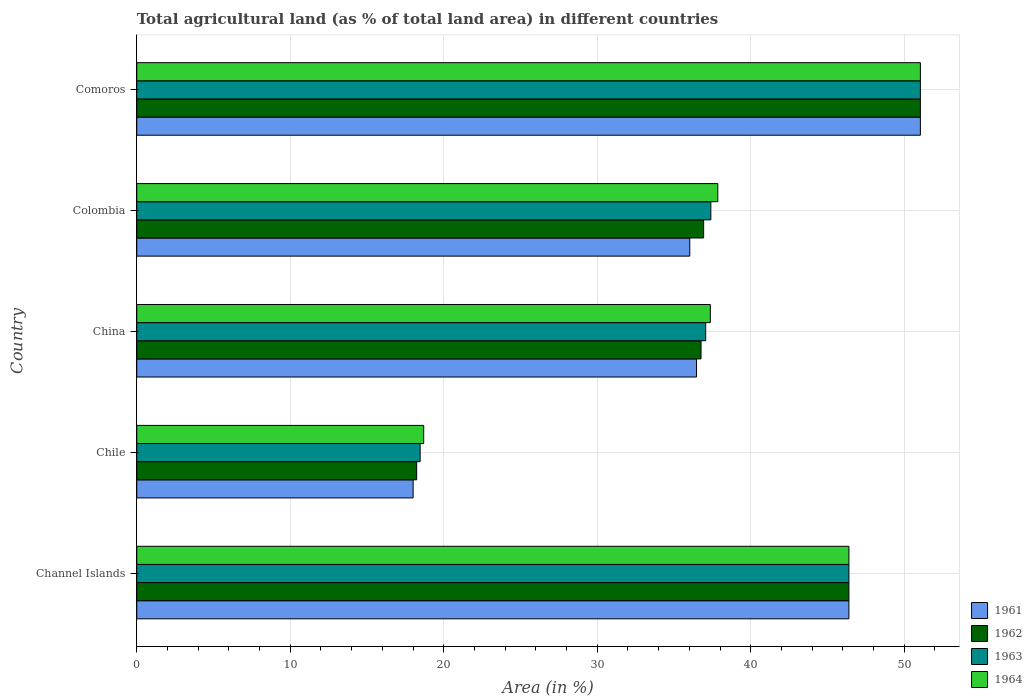In how many cases, is the number of bars for a given country not equal to the number of legend labels?
Your answer should be very brief. 0. What is the percentage of agricultural land in 1962 in Channel Islands?
Ensure brevity in your answer.  46.39. Across all countries, what is the maximum percentage of agricultural land in 1963?
Keep it short and to the point. 51.05. Across all countries, what is the minimum percentage of agricultural land in 1963?
Provide a short and direct response. 18.46. In which country was the percentage of agricultural land in 1963 maximum?
Offer a terse response. Comoros. What is the total percentage of agricultural land in 1962 in the graph?
Offer a terse response. 189.36. What is the difference between the percentage of agricultural land in 1962 in China and that in Comoros?
Your answer should be very brief. -14.29. What is the difference between the percentage of agricultural land in 1962 in Colombia and the percentage of agricultural land in 1963 in Chile?
Your answer should be very brief. 18.47. What is the average percentage of agricultural land in 1963 per country?
Your answer should be very brief. 38.07. In how many countries, is the percentage of agricultural land in 1962 greater than 22 %?
Offer a very short reply. 4. What is the ratio of the percentage of agricultural land in 1961 in Channel Islands to that in Colombia?
Your answer should be compact. 1.29. Is the percentage of agricultural land in 1964 in Colombia less than that in Comoros?
Offer a very short reply. Yes. Is the difference between the percentage of agricultural land in 1962 in Channel Islands and Chile greater than the difference between the percentage of agricultural land in 1963 in Channel Islands and Chile?
Your answer should be compact. Yes. What is the difference between the highest and the second highest percentage of agricultural land in 1963?
Your answer should be very brief. 4.66. What is the difference between the highest and the lowest percentage of agricultural land in 1962?
Provide a succinct answer. 32.82. In how many countries, is the percentage of agricultural land in 1961 greater than the average percentage of agricultural land in 1961 taken over all countries?
Ensure brevity in your answer.  2. What does the 1st bar from the top in Colombia represents?
Your answer should be very brief. 1964. How many bars are there?
Offer a very short reply. 20. How many countries are there in the graph?
Make the answer very short. 5. Are the values on the major ticks of X-axis written in scientific E-notation?
Your response must be concise. No. Where does the legend appear in the graph?
Provide a succinct answer. Bottom right. How many legend labels are there?
Provide a short and direct response. 4. What is the title of the graph?
Offer a terse response. Total agricultural land (as % of total land area) in different countries. Does "1964" appear as one of the legend labels in the graph?
Provide a succinct answer. Yes. What is the label or title of the X-axis?
Your answer should be very brief. Area (in %). What is the label or title of the Y-axis?
Make the answer very short. Country. What is the Area (in %) of 1961 in Channel Islands?
Your response must be concise. 46.39. What is the Area (in %) in 1962 in Channel Islands?
Provide a succinct answer. 46.39. What is the Area (in %) in 1963 in Channel Islands?
Provide a succinct answer. 46.39. What is the Area (in %) of 1964 in Channel Islands?
Provide a short and direct response. 46.39. What is the Area (in %) of 1961 in Chile?
Offer a terse response. 18. What is the Area (in %) in 1962 in Chile?
Your answer should be compact. 18.23. What is the Area (in %) of 1963 in Chile?
Keep it short and to the point. 18.46. What is the Area (in %) of 1964 in Chile?
Your response must be concise. 18.69. What is the Area (in %) in 1961 in China?
Make the answer very short. 36.47. What is the Area (in %) in 1962 in China?
Offer a very short reply. 36.76. What is the Area (in %) of 1963 in China?
Your answer should be very brief. 37.06. What is the Area (in %) of 1964 in China?
Provide a succinct answer. 37.37. What is the Area (in %) in 1961 in Colombia?
Your response must be concise. 36.03. What is the Area (in %) in 1962 in Colombia?
Give a very brief answer. 36.93. What is the Area (in %) of 1963 in Colombia?
Your response must be concise. 37.4. What is the Area (in %) in 1964 in Colombia?
Your answer should be compact. 37.85. What is the Area (in %) of 1961 in Comoros?
Your answer should be very brief. 51.05. What is the Area (in %) of 1962 in Comoros?
Offer a very short reply. 51.05. What is the Area (in %) in 1963 in Comoros?
Offer a terse response. 51.05. What is the Area (in %) of 1964 in Comoros?
Ensure brevity in your answer.  51.05. Across all countries, what is the maximum Area (in %) of 1961?
Give a very brief answer. 51.05. Across all countries, what is the maximum Area (in %) in 1962?
Provide a short and direct response. 51.05. Across all countries, what is the maximum Area (in %) of 1963?
Keep it short and to the point. 51.05. Across all countries, what is the maximum Area (in %) in 1964?
Provide a short and direct response. 51.05. Across all countries, what is the minimum Area (in %) in 1961?
Your answer should be compact. 18. Across all countries, what is the minimum Area (in %) of 1962?
Your response must be concise. 18.23. Across all countries, what is the minimum Area (in %) of 1963?
Offer a terse response. 18.46. Across all countries, what is the minimum Area (in %) in 1964?
Your response must be concise. 18.69. What is the total Area (in %) of 1961 in the graph?
Offer a very short reply. 187.93. What is the total Area (in %) of 1962 in the graph?
Give a very brief answer. 189.36. What is the total Area (in %) in 1963 in the graph?
Your answer should be compact. 190.36. What is the total Area (in %) of 1964 in the graph?
Offer a terse response. 191.35. What is the difference between the Area (in %) of 1961 in Channel Islands and that in Chile?
Keep it short and to the point. 28.39. What is the difference between the Area (in %) in 1962 in Channel Islands and that in Chile?
Your answer should be very brief. 28.16. What is the difference between the Area (in %) in 1963 in Channel Islands and that in Chile?
Keep it short and to the point. 27.93. What is the difference between the Area (in %) in 1964 in Channel Islands and that in Chile?
Ensure brevity in your answer.  27.7. What is the difference between the Area (in %) in 1961 in Channel Islands and that in China?
Your answer should be compact. 9.93. What is the difference between the Area (in %) in 1962 in Channel Islands and that in China?
Your answer should be very brief. 9.63. What is the difference between the Area (in %) in 1963 in Channel Islands and that in China?
Provide a succinct answer. 9.33. What is the difference between the Area (in %) in 1964 in Channel Islands and that in China?
Provide a succinct answer. 9.03. What is the difference between the Area (in %) of 1961 in Channel Islands and that in Colombia?
Your response must be concise. 10.37. What is the difference between the Area (in %) of 1962 in Channel Islands and that in Colombia?
Your answer should be very brief. 9.46. What is the difference between the Area (in %) in 1963 in Channel Islands and that in Colombia?
Give a very brief answer. 8.99. What is the difference between the Area (in %) of 1964 in Channel Islands and that in Colombia?
Give a very brief answer. 8.54. What is the difference between the Area (in %) of 1961 in Channel Islands and that in Comoros?
Your answer should be compact. -4.66. What is the difference between the Area (in %) of 1962 in Channel Islands and that in Comoros?
Provide a short and direct response. -4.66. What is the difference between the Area (in %) of 1963 in Channel Islands and that in Comoros?
Make the answer very short. -4.66. What is the difference between the Area (in %) in 1964 in Channel Islands and that in Comoros?
Make the answer very short. -4.66. What is the difference between the Area (in %) of 1961 in Chile and that in China?
Your response must be concise. -18.46. What is the difference between the Area (in %) in 1962 in Chile and that in China?
Your response must be concise. -18.53. What is the difference between the Area (in %) of 1963 in Chile and that in China?
Your answer should be compact. -18.6. What is the difference between the Area (in %) in 1964 in Chile and that in China?
Your answer should be compact. -18.67. What is the difference between the Area (in %) of 1961 in Chile and that in Colombia?
Your response must be concise. -18.02. What is the difference between the Area (in %) of 1962 in Chile and that in Colombia?
Your answer should be very brief. -18.7. What is the difference between the Area (in %) in 1963 in Chile and that in Colombia?
Your answer should be compact. -18.94. What is the difference between the Area (in %) of 1964 in Chile and that in Colombia?
Make the answer very short. -19.16. What is the difference between the Area (in %) of 1961 in Chile and that in Comoros?
Offer a very short reply. -33.04. What is the difference between the Area (in %) of 1962 in Chile and that in Comoros?
Keep it short and to the point. -32.82. What is the difference between the Area (in %) in 1963 in Chile and that in Comoros?
Your answer should be compact. -32.59. What is the difference between the Area (in %) of 1964 in Chile and that in Comoros?
Your answer should be compact. -32.36. What is the difference between the Area (in %) of 1961 in China and that in Colombia?
Your answer should be very brief. 0.44. What is the difference between the Area (in %) of 1962 in China and that in Colombia?
Your answer should be very brief. -0.17. What is the difference between the Area (in %) in 1963 in China and that in Colombia?
Offer a terse response. -0.34. What is the difference between the Area (in %) of 1964 in China and that in Colombia?
Your answer should be very brief. -0.48. What is the difference between the Area (in %) of 1961 in China and that in Comoros?
Keep it short and to the point. -14.58. What is the difference between the Area (in %) in 1962 in China and that in Comoros?
Your response must be concise. -14.29. What is the difference between the Area (in %) of 1963 in China and that in Comoros?
Provide a short and direct response. -13.99. What is the difference between the Area (in %) of 1964 in China and that in Comoros?
Provide a succinct answer. -13.68. What is the difference between the Area (in %) in 1961 in Colombia and that in Comoros?
Offer a very short reply. -15.02. What is the difference between the Area (in %) of 1962 in Colombia and that in Comoros?
Your response must be concise. -14.12. What is the difference between the Area (in %) in 1963 in Colombia and that in Comoros?
Your answer should be compact. -13.65. What is the difference between the Area (in %) in 1964 in Colombia and that in Comoros?
Keep it short and to the point. -13.2. What is the difference between the Area (in %) in 1961 in Channel Islands and the Area (in %) in 1962 in Chile?
Offer a very short reply. 28.16. What is the difference between the Area (in %) in 1961 in Channel Islands and the Area (in %) in 1963 in Chile?
Give a very brief answer. 27.93. What is the difference between the Area (in %) of 1961 in Channel Islands and the Area (in %) of 1964 in Chile?
Keep it short and to the point. 27.7. What is the difference between the Area (in %) in 1962 in Channel Islands and the Area (in %) in 1963 in Chile?
Offer a very short reply. 27.93. What is the difference between the Area (in %) in 1962 in Channel Islands and the Area (in %) in 1964 in Chile?
Provide a succinct answer. 27.7. What is the difference between the Area (in %) in 1963 in Channel Islands and the Area (in %) in 1964 in Chile?
Make the answer very short. 27.7. What is the difference between the Area (in %) in 1961 in Channel Islands and the Area (in %) in 1962 in China?
Keep it short and to the point. 9.63. What is the difference between the Area (in %) of 1961 in Channel Islands and the Area (in %) of 1963 in China?
Keep it short and to the point. 9.33. What is the difference between the Area (in %) in 1961 in Channel Islands and the Area (in %) in 1964 in China?
Offer a terse response. 9.03. What is the difference between the Area (in %) of 1962 in Channel Islands and the Area (in %) of 1963 in China?
Give a very brief answer. 9.33. What is the difference between the Area (in %) in 1962 in Channel Islands and the Area (in %) in 1964 in China?
Offer a very short reply. 9.03. What is the difference between the Area (in %) in 1963 in Channel Islands and the Area (in %) in 1964 in China?
Ensure brevity in your answer.  9.03. What is the difference between the Area (in %) of 1961 in Channel Islands and the Area (in %) of 1962 in Colombia?
Keep it short and to the point. 9.46. What is the difference between the Area (in %) in 1961 in Channel Islands and the Area (in %) in 1963 in Colombia?
Your answer should be very brief. 8.99. What is the difference between the Area (in %) of 1961 in Channel Islands and the Area (in %) of 1964 in Colombia?
Your answer should be very brief. 8.54. What is the difference between the Area (in %) in 1962 in Channel Islands and the Area (in %) in 1963 in Colombia?
Keep it short and to the point. 8.99. What is the difference between the Area (in %) in 1962 in Channel Islands and the Area (in %) in 1964 in Colombia?
Make the answer very short. 8.54. What is the difference between the Area (in %) of 1963 in Channel Islands and the Area (in %) of 1964 in Colombia?
Your response must be concise. 8.54. What is the difference between the Area (in %) in 1961 in Channel Islands and the Area (in %) in 1962 in Comoros?
Your answer should be very brief. -4.66. What is the difference between the Area (in %) in 1961 in Channel Islands and the Area (in %) in 1963 in Comoros?
Your response must be concise. -4.66. What is the difference between the Area (in %) in 1961 in Channel Islands and the Area (in %) in 1964 in Comoros?
Offer a very short reply. -4.66. What is the difference between the Area (in %) of 1962 in Channel Islands and the Area (in %) of 1963 in Comoros?
Make the answer very short. -4.66. What is the difference between the Area (in %) in 1962 in Channel Islands and the Area (in %) in 1964 in Comoros?
Keep it short and to the point. -4.66. What is the difference between the Area (in %) of 1963 in Channel Islands and the Area (in %) of 1964 in Comoros?
Provide a succinct answer. -4.66. What is the difference between the Area (in %) in 1961 in Chile and the Area (in %) in 1962 in China?
Keep it short and to the point. -18.76. What is the difference between the Area (in %) in 1961 in Chile and the Area (in %) in 1963 in China?
Give a very brief answer. -19.06. What is the difference between the Area (in %) in 1961 in Chile and the Area (in %) in 1964 in China?
Offer a very short reply. -19.36. What is the difference between the Area (in %) of 1962 in Chile and the Area (in %) of 1963 in China?
Offer a very short reply. -18.83. What is the difference between the Area (in %) in 1962 in Chile and the Area (in %) in 1964 in China?
Provide a succinct answer. -19.13. What is the difference between the Area (in %) in 1963 in Chile and the Area (in %) in 1964 in China?
Ensure brevity in your answer.  -18.91. What is the difference between the Area (in %) of 1961 in Chile and the Area (in %) of 1962 in Colombia?
Offer a very short reply. -18.93. What is the difference between the Area (in %) of 1961 in Chile and the Area (in %) of 1963 in Colombia?
Offer a terse response. -19.39. What is the difference between the Area (in %) in 1961 in Chile and the Area (in %) in 1964 in Colombia?
Provide a succinct answer. -19.85. What is the difference between the Area (in %) of 1962 in Chile and the Area (in %) of 1963 in Colombia?
Provide a short and direct response. -19.17. What is the difference between the Area (in %) of 1962 in Chile and the Area (in %) of 1964 in Colombia?
Make the answer very short. -19.62. What is the difference between the Area (in %) of 1963 in Chile and the Area (in %) of 1964 in Colombia?
Give a very brief answer. -19.39. What is the difference between the Area (in %) in 1961 in Chile and the Area (in %) in 1962 in Comoros?
Ensure brevity in your answer.  -33.04. What is the difference between the Area (in %) in 1961 in Chile and the Area (in %) in 1963 in Comoros?
Make the answer very short. -33.04. What is the difference between the Area (in %) of 1961 in Chile and the Area (in %) of 1964 in Comoros?
Make the answer very short. -33.04. What is the difference between the Area (in %) of 1962 in Chile and the Area (in %) of 1963 in Comoros?
Keep it short and to the point. -32.82. What is the difference between the Area (in %) in 1962 in Chile and the Area (in %) in 1964 in Comoros?
Your answer should be very brief. -32.82. What is the difference between the Area (in %) in 1963 in Chile and the Area (in %) in 1964 in Comoros?
Keep it short and to the point. -32.59. What is the difference between the Area (in %) of 1961 in China and the Area (in %) of 1962 in Colombia?
Keep it short and to the point. -0.46. What is the difference between the Area (in %) in 1961 in China and the Area (in %) in 1963 in Colombia?
Offer a very short reply. -0.93. What is the difference between the Area (in %) of 1961 in China and the Area (in %) of 1964 in Colombia?
Keep it short and to the point. -1.38. What is the difference between the Area (in %) in 1962 in China and the Area (in %) in 1963 in Colombia?
Keep it short and to the point. -0.64. What is the difference between the Area (in %) of 1962 in China and the Area (in %) of 1964 in Colombia?
Make the answer very short. -1.09. What is the difference between the Area (in %) of 1963 in China and the Area (in %) of 1964 in Colombia?
Your answer should be compact. -0.79. What is the difference between the Area (in %) in 1961 in China and the Area (in %) in 1962 in Comoros?
Ensure brevity in your answer.  -14.58. What is the difference between the Area (in %) of 1961 in China and the Area (in %) of 1963 in Comoros?
Make the answer very short. -14.58. What is the difference between the Area (in %) of 1961 in China and the Area (in %) of 1964 in Comoros?
Offer a terse response. -14.58. What is the difference between the Area (in %) of 1962 in China and the Area (in %) of 1963 in Comoros?
Give a very brief answer. -14.29. What is the difference between the Area (in %) of 1962 in China and the Area (in %) of 1964 in Comoros?
Keep it short and to the point. -14.29. What is the difference between the Area (in %) in 1963 in China and the Area (in %) in 1964 in Comoros?
Keep it short and to the point. -13.99. What is the difference between the Area (in %) of 1961 in Colombia and the Area (in %) of 1962 in Comoros?
Your answer should be very brief. -15.02. What is the difference between the Area (in %) in 1961 in Colombia and the Area (in %) in 1963 in Comoros?
Offer a very short reply. -15.02. What is the difference between the Area (in %) in 1961 in Colombia and the Area (in %) in 1964 in Comoros?
Offer a terse response. -15.02. What is the difference between the Area (in %) in 1962 in Colombia and the Area (in %) in 1963 in Comoros?
Your response must be concise. -14.12. What is the difference between the Area (in %) of 1962 in Colombia and the Area (in %) of 1964 in Comoros?
Offer a very short reply. -14.12. What is the difference between the Area (in %) of 1963 in Colombia and the Area (in %) of 1964 in Comoros?
Provide a short and direct response. -13.65. What is the average Area (in %) in 1961 per country?
Give a very brief answer. 37.59. What is the average Area (in %) of 1962 per country?
Your answer should be compact. 37.87. What is the average Area (in %) of 1963 per country?
Your response must be concise. 38.07. What is the average Area (in %) in 1964 per country?
Your response must be concise. 38.27. What is the difference between the Area (in %) in 1961 and Area (in %) in 1962 in Channel Islands?
Offer a very short reply. 0. What is the difference between the Area (in %) in 1962 and Area (in %) in 1964 in Channel Islands?
Give a very brief answer. 0. What is the difference between the Area (in %) in 1961 and Area (in %) in 1962 in Chile?
Offer a very short reply. -0.23. What is the difference between the Area (in %) in 1961 and Area (in %) in 1963 in Chile?
Your answer should be very brief. -0.46. What is the difference between the Area (in %) of 1961 and Area (in %) of 1964 in Chile?
Make the answer very short. -0.69. What is the difference between the Area (in %) of 1962 and Area (in %) of 1963 in Chile?
Make the answer very short. -0.23. What is the difference between the Area (in %) in 1962 and Area (in %) in 1964 in Chile?
Ensure brevity in your answer.  -0.46. What is the difference between the Area (in %) in 1963 and Area (in %) in 1964 in Chile?
Keep it short and to the point. -0.23. What is the difference between the Area (in %) in 1961 and Area (in %) in 1962 in China?
Offer a terse response. -0.29. What is the difference between the Area (in %) in 1961 and Area (in %) in 1963 in China?
Your response must be concise. -0.6. What is the difference between the Area (in %) in 1961 and Area (in %) in 1964 in China?
Keep it short and to the point. -0.9. What is the difference between the Area (in %) in 1962 and Area (in %) in 1963 in China?
Your answer should be compact. -0.3. What is the difference between the Area (in %) in 1962 and Area (in %) in 1964 in China?
Give a very brief answer. -0.61. What is the difference between the Area (in %) in 1963 and Area (in %) in 1964 in China?
Provide a succinct answer. -0.3. What is the difference between the Area (in %) in 1961 and Area (in %) in 1962 in Colombia?
Give a very brief answer. -0.9. What is the difference between the Area (in %) of 1961 and Area (in %) of 1963 in Colombia?
Provide a succinct answer. -1.37. What is the difference between the Area (in %) of 1961 and Area (in %) of 1964 in Colombia?
Your answer should be very brief. -1.83. What is the difference between the Area (in %) in 1962 and Area (in %) in 1963 in Colombia?
Keep it short and to the point. -0.47. What is the difference between the Area (in %) in 1962 and Area (in %) in 1964 in Colombia?
Give a very brief answer. -0.92. What is the difference between the Area (in %) in 1963 and Area (in %) in 1964 in Colombia?
Your response must be concise. -0.45. What is the difference between the Area (in %) in 1961 and Area (in %) in 1962 in Comoros?
Offer a terse response. 0. What is the difference between the Area (in %) in 1961 and Area (in %) in 1964 in Comoros?
Your answer should be compact. 0. What is the difference between the Area (in %) of 1962 and Area (in %) of 1963 in Comoros?
Offer a very short reply. 0. What is the difference between the Area (in %) in 1963 and Area (in %) in 1964 in Comoros?
Your response must be concise. 0. What is the ratio of the Area (in %) of 1961 in Channel Islands to that in Chile?
Offer a terse response. 2.58. What is the ratio of the Area (in %) of 1962 in Channel Islands to that in Chile?
Provide a succinct answer. 2.54. What is the ratio of the Area (in %) in 1963 in Channel Islands to that in Chile?
Your answer should be very brief. 2.51. What is the ratio of the Area (in %) of 1964 in Channel Islands to that in Chile?
Your answer should be very brief. 2.48. What is the ratio of the Area (in %) of 1961 in Channel Islands to that in China?
Your answer should be very brief. 1.27. What is the ratio of the Area (in %) of 1962 in Channel Islands to that in China?
Your response must be concise. 1.26. What is the ratio of the Area (in %) in 1963 in Channel Islands to that in China?
Offer a terse response. 1.25. What is the ratio of the Area (in %) in 1964 in Channel Islands to that in China?
Your answer should be compact. 1.24. What is the ratio of the Area (in %) of 1961 in Channel Islands to that in Colombia?
Ensure brevity in your answer.  1.29. What is the ratio of the Area (in %) of 1962 in Channel Islands to that in Colombia?
Offer a very short reply. 1.26. What is the ratio of the Area (in %) in 1963 in Channel Islands to that in Colombia?
Your answer should be very brief. 1.24. What is the ratio of the Area (in %) in 1964 in Channel Islands to that in Colombia?
Your answer should be very brief. 1.23. What is the ratio of the Area (in %) in 1961 in Channel Islands to that in Comoros?
Give a very brief answer. 0.91. What is the ratio of the Area (in %) of 1962 in Channel Islands to that in Comoros?
Offer a very short reply. 0.91. What is the ratio of the Area (in %) in 1963 in Channel Islands to that in Comoros?
Offer a terse response. 0.91. What is the ratio of the Area (in %) in 1964 in Channel Islands to that in Comoros?
Offer a very short reply. 0.91. What is the ratio of the Area (in %) in 1961 in Chile to that in China?
Give a very brief answer. 0.49. What is the ratio of the Area (in %) of 1962 in Chile to that in China?
Make the answer very short. 0.5. What is the ratio of the Area (in %) in 1963 in Chile to that in China?
Give a very brief answer. 0.5. What is the ratio of the Area (in %) of 1964 in Chile to that in China?
Keep it short and to the point. 0.5. What is the ratio of the Area (in %) in 1961 in Chile to that in Colombia?
Your answer should be compact. 0.5. What is the ratio of the Area (in %) in 1962 in Chile to that in Colombia?
Your response must be concise. 0.49. What is the ratio of the Area (in %) in 1963 in Chile to that in Colombia?
Ensure brevity in your answer.  0.49. What is the ratio of the Area (in %) in 1964 in Chile to that in Colombia?
Provide a short and direct response. 0.49. What is the ratio of the Area (in %) of 1961 in Chile to that in Comoros?
Offer a very short reply. 0.35. What is the ratio of the Area (in %) of 1962 in Chile to that in Comoros?
Give a very brief answer. 0.36. What is the ratio of the Area (in %) in 1963 in Chile to that in Comoros?
Your answer should be compact. 0.36. What is the ratio of the Area (in %) of 1964 in Chile to that in Comoros?
Your answer should be compact. 0.37. What is the ratio of the Area (in %) in 1961 in China to that in Colombia?
Your response must be concise. 1.01. What is the ratio of the Area (in %) in 1963 in China to that in Colombia?
Offer a terse response. 0.99. What is the ratio of the Area (in %) of 1964 in China to that in Colombia?
Offer a terse response. 0.99. What is the ratio of the Area (in %) of 1961 in China to that in Comoros?
Your answer should be very brief. 0.71. What is the ratio of the Area (in %) of 1962 in China to that in Comoros?
Your answer should be very brief. 0.72. What is the ratio of the Area (in %) in 1963 in China to that in Comoros?
Your answer should be very brief. 0.73. What is the ratio of the Area (in %) of 1964 in China to that in Comoros?
Give a very brief answer. 0.73. What is the ratio of the Area (in %) of 1961 in Colombia to that in Comoros?
Keep it short and to the point. 0.71. What is the ratio of the Area (in %) of 1962 in Colombia to that in Comoros?
Ensure brevity in your answer.  0.72. What is the ratio of the Area (in %) of 1963 in Colombia to that in Comoros?
Your answer should be very brief. 0.73. What is the ratio of the Area (in %) in 1964 in Colombia to that in Comoros?
Your response must be concise. 0.74. What is the difference between the highest and the second highest Area (in %) in 1961?
Provide a succinct answer. 4.66. What is the difference between the highest and the second highest Area (in %) of 1962?
Your answer should be compact. 4.66. What is the difference between the highest and the second highest Area (in %) in 1963?
Your answer should be very brief. 4.66. What is the difference between the highest and the second highest Area (in %) of 1964?
Your answer should be very brief. 4.66. What is the difference between the highest and the lowest Area (in %) of 1961?
Your response must be concise. 33.04. What is the difference between the highest and the lowest Area (in %) of 1962?
Your answer should be very brief. 32.82. What is the difference between the highest and the lowest Area (in %) of 1963?
Give a very brief answer. 32.59. What is the difference between the highest and the lowest Area (in %) of 1964?
Keep it short and to the point. 32.36. 